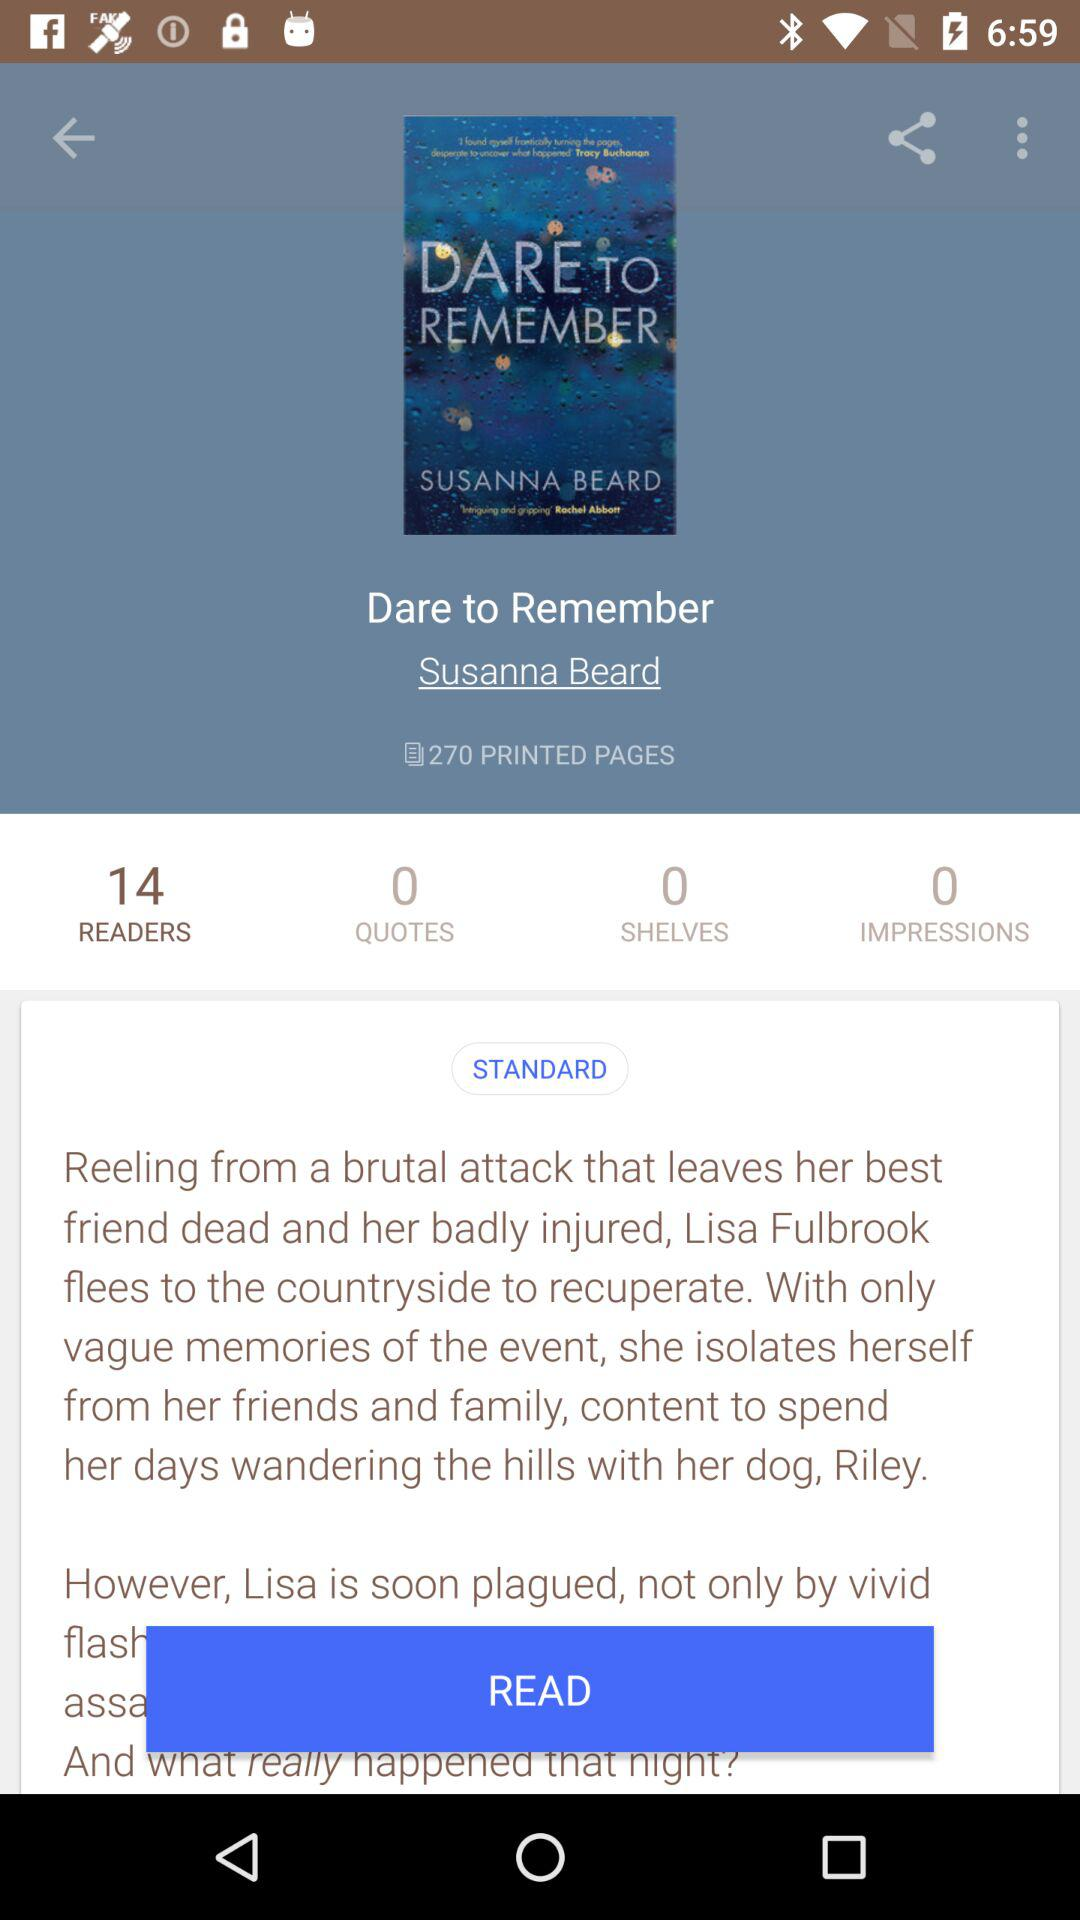What's the number of impressions? The number of impressions is 0. 